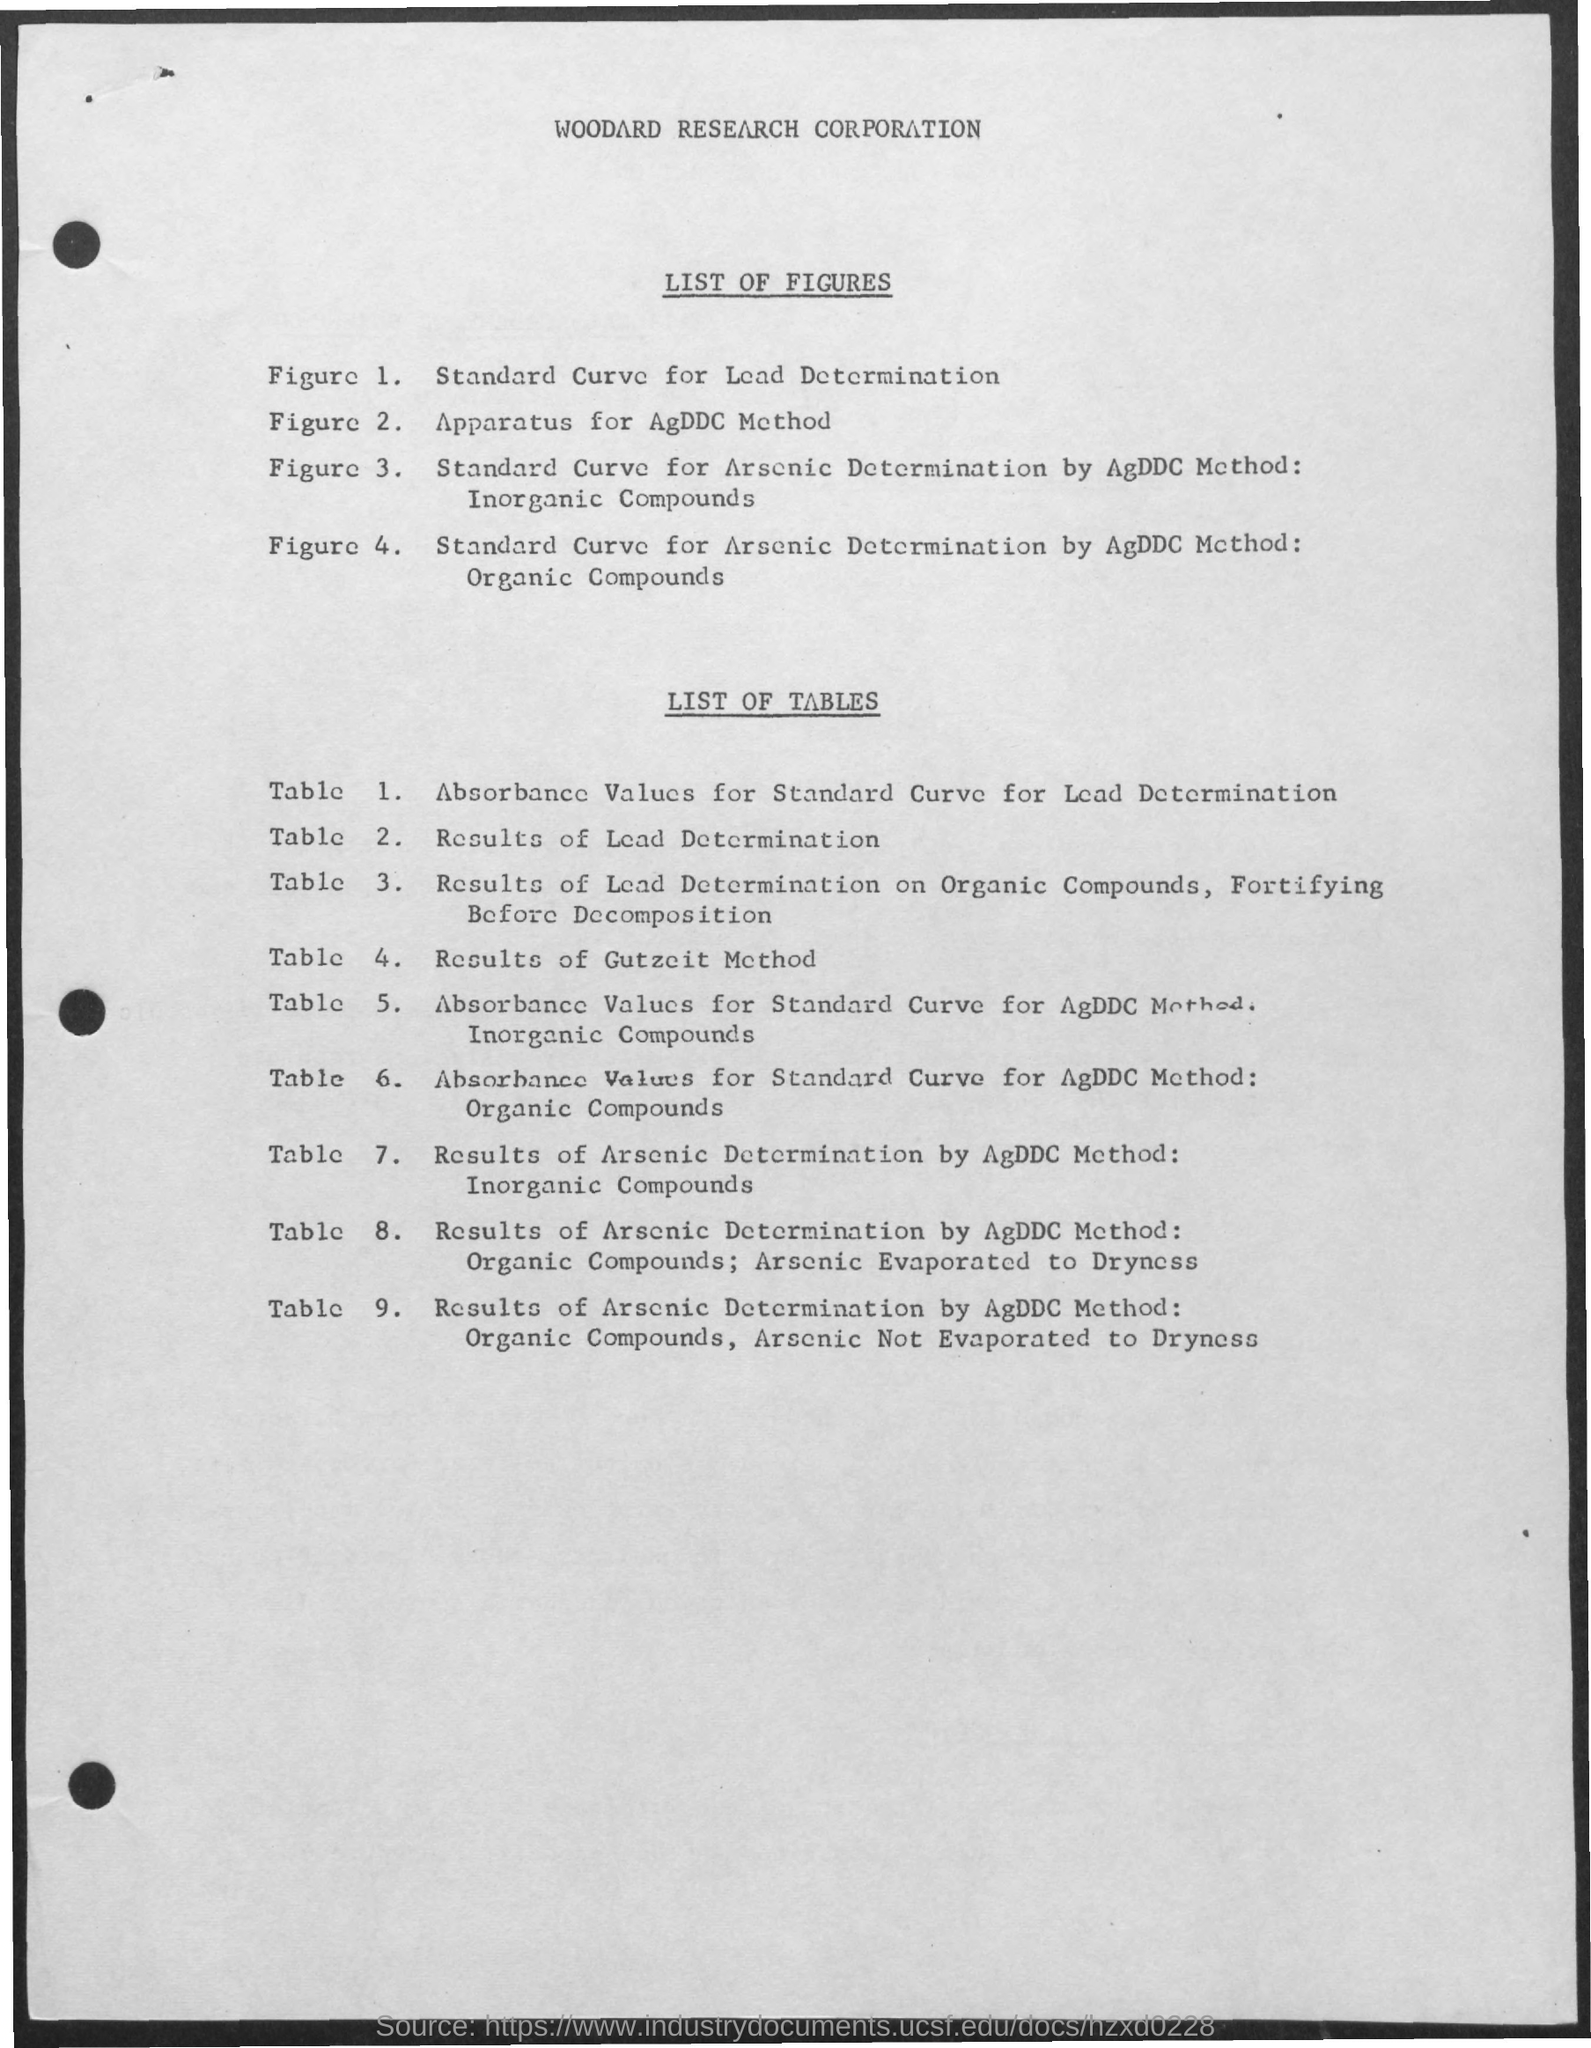Outline some significant characteristics in this image. The first title in the document is "Woodard Research Corporation. The document contains a second title that reads "List of Figures. The third title in the document is List of Tables. 